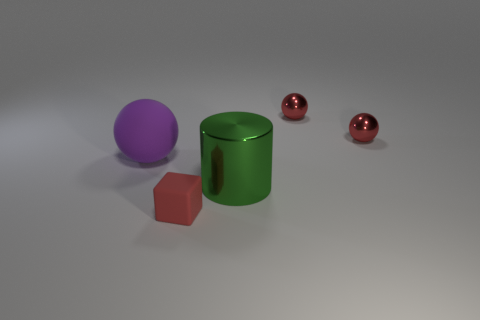Does the cube have the same color as the large sphere?
Keep it short and to the point. No. How many large green shiny objects have the same shape as the purple thing?
Give a very brief answer. 0. There is a red thing that is made of the same material as the purple object; what is its size?
Give a very brief answer. Small. There is a object that is both to the left of the big cylinder and behind the big green metallic cylinder; what color is it?
Make the answer very short. Purple. What number of rubber things are the same size as the green metal object?
Your answer should be very brief. 1. How big is the thing that is in front of the large matte sphere and behind the tiny red matte block?
Offer a terse response. Large. How many tiny things are in front of the large cylinder that is to the right of the rubber thing that is in front of the large matte thing?
Offer a very short reply. 1. Are there any shiny objects that have the same color as the tiny matte object?
Make the answer very short. Yes. The rubber sphere that is the same size as the green metal cylinder is what color?
Provide a short and direct response. Purple. There is a large thing in front of the sphere on the left side of the red thing that is in front of the shiny cylinder; what is its shape?
Offer a very short reply. Cylinder. 